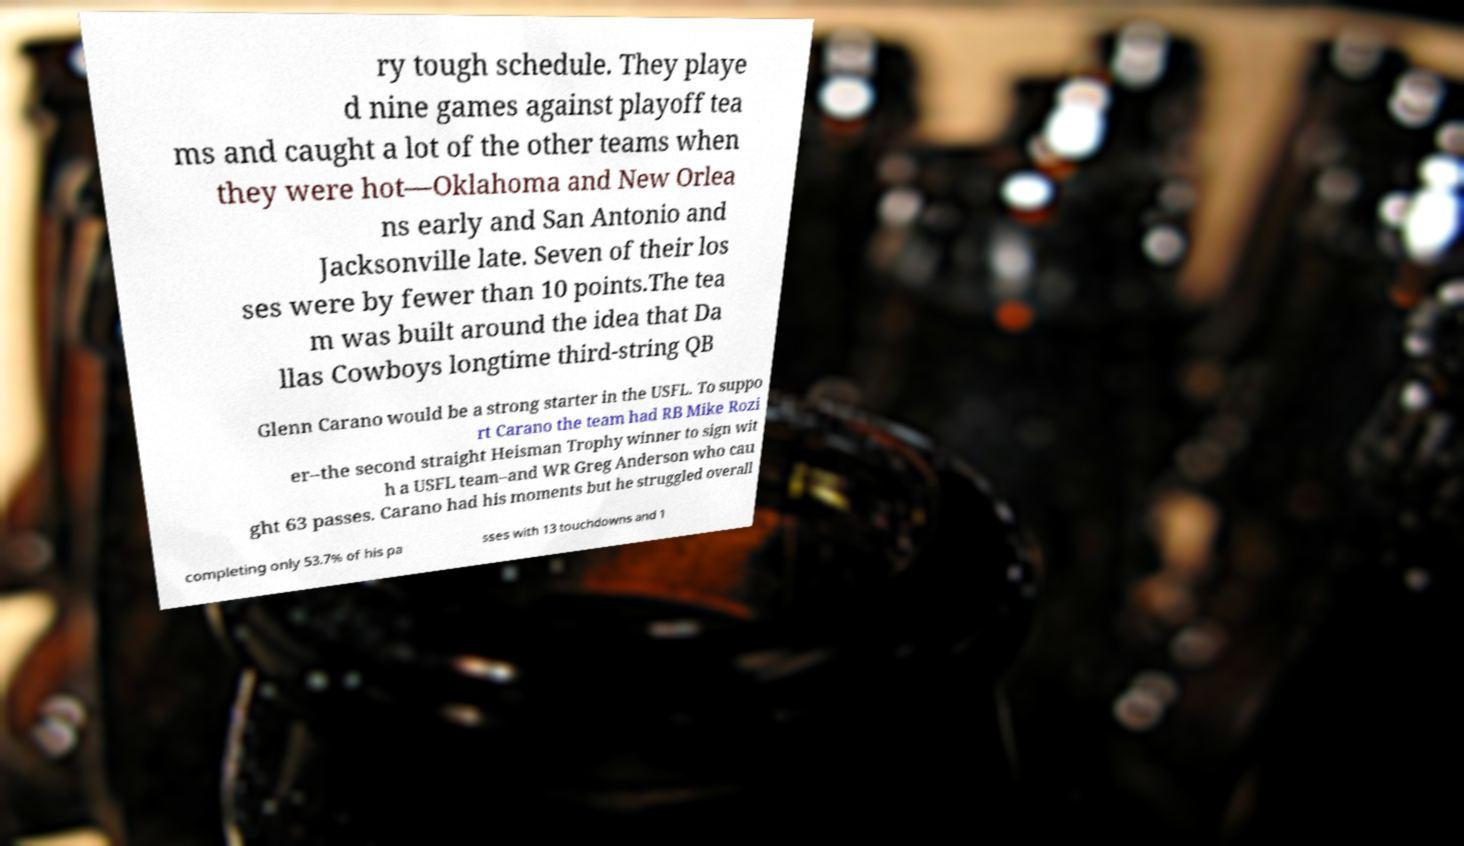Please identify and transcribe the text found in this image. ry tough schedule. They playe d nine games against playoff tea ms and caught a lot of the other teams when they were hot—Oklahoma and New Orlea ns early and San Antonio and Jacksonville late. Seven of their los ses were by fewer than 10 points.The tea m was built around the idea that Da llas Cowboys longtime third-string QB Glenn Carano would be a strong starter in the USFL. To suppo rt Carano the team had RB Mike Rozi er–the second straight Heisman Trophy winner to sign wit h a USFL team–and WR Greg Anderson who cau ght 63 passes. Carano had his moments but he struggled overall completing only 53.7% of his pa sses with 13 touchdowns and 1 